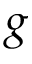<formula> <loc_0><loc_0><loc_500><loc_500>g</formula> 